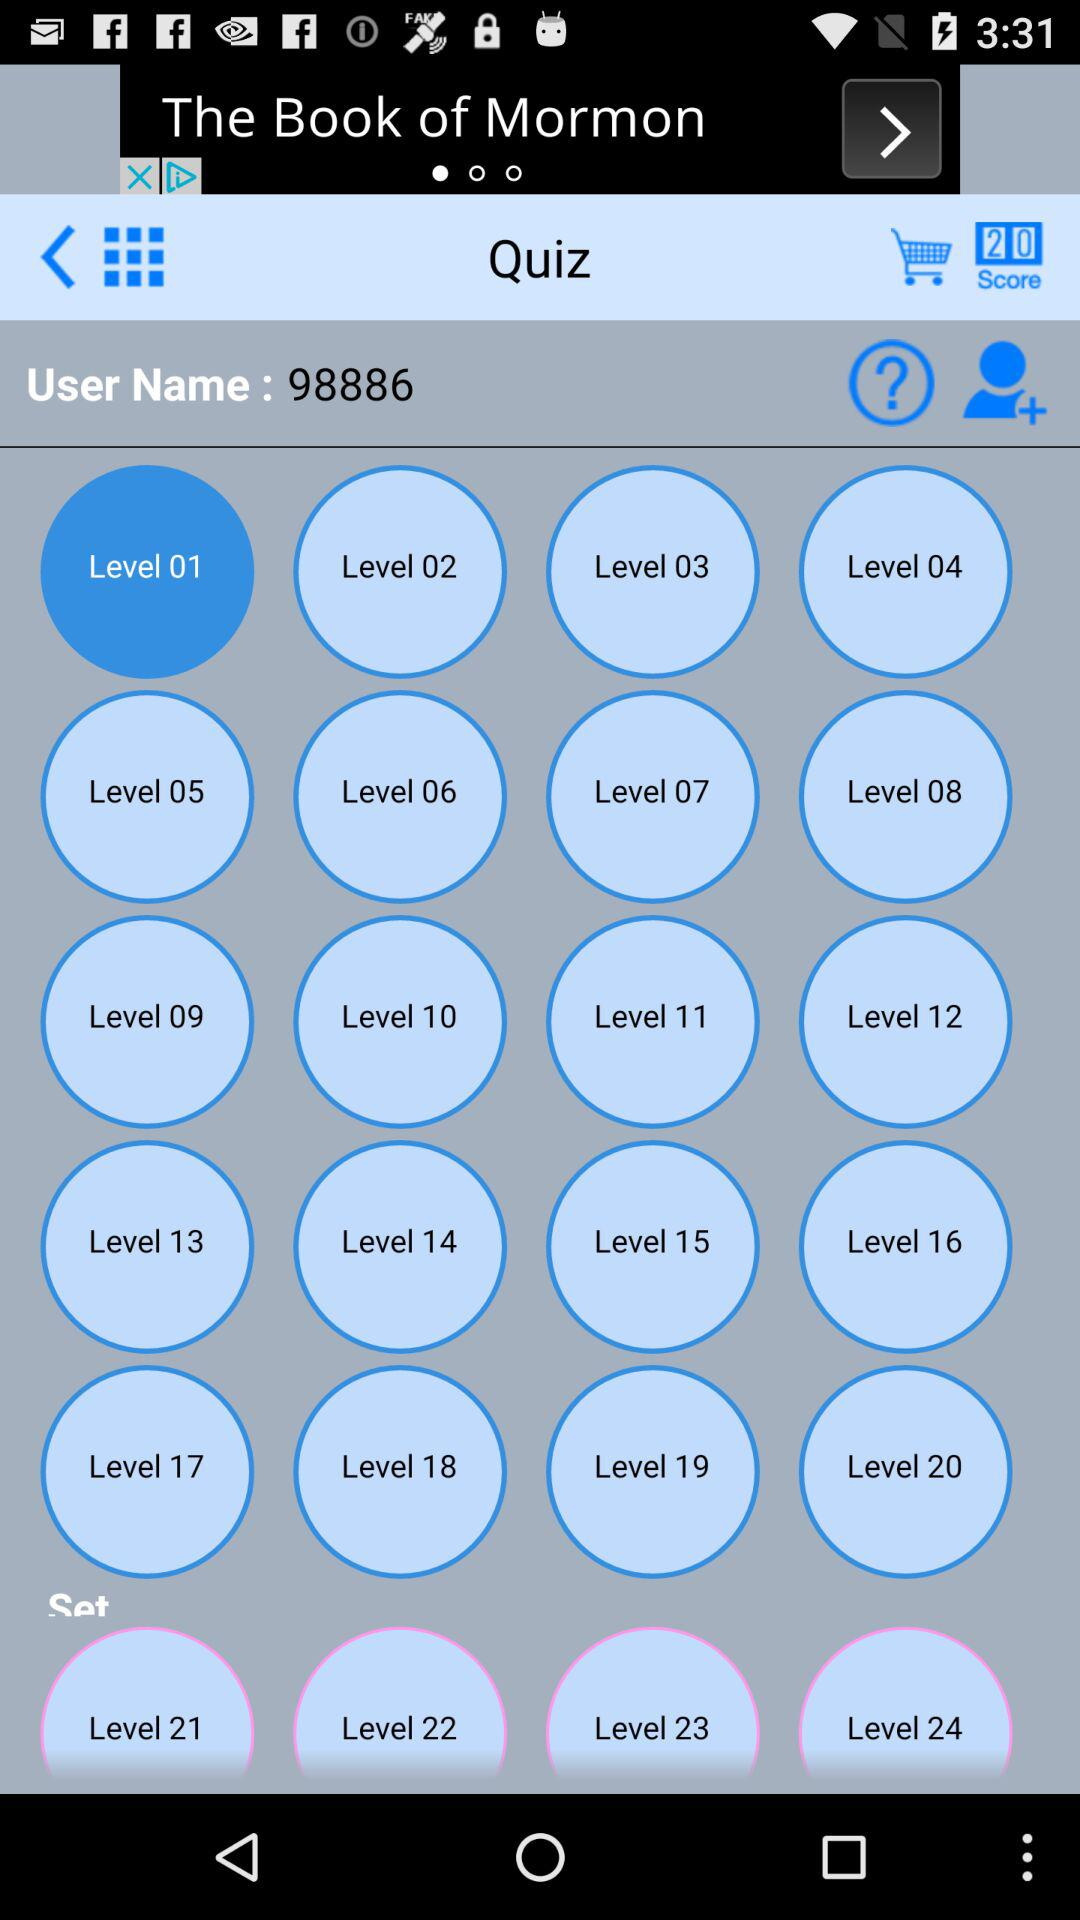How many levels are there in the quiz?
Answer the question using a single word or phrase. 24 